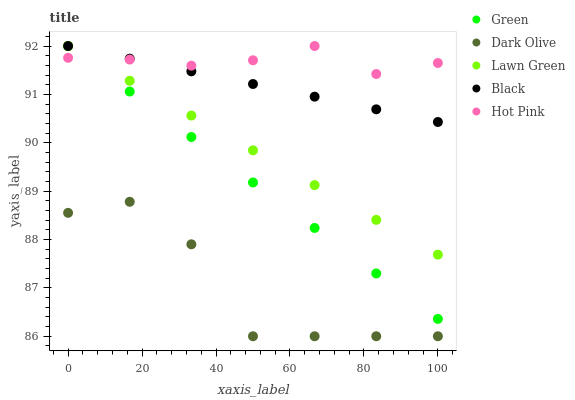Does Dark Olive have the minimum area under the curve?
Answer yes or no. Yes. Does Hot Pink have the maximum area under the curve?
Answer yes or no. Yes. Does Green have the minimum area under the curve?
Answer yes or no. No. Does Green have the maximum area under the curve?
Answer yes or no. No. Is Black the smoothest?
Answer yes or no. Yes. Is Dark Olive the roughest?
Answer yes or no. Yes. Is Green the smoothest?
Answer yes or no. No. Is Green the roughest?
Answer yes or no. No. Does Dark Olive have the lowest value?
Answer yes or no. Yes. Does Green have the lowest value?
Answer yes or no. No. Does Hot Pink have the highest value?
Answer yes or no. Yes. Does Dark Olive have the highest value?
Answer yes or no. No. Is Dark Olive less than Green?
Answer yes or no. Yes. Is Hot Pink greater than Dark Olive?
Answer yes or no. Yes. Does Black intersect Hot Pink?
Answer yes or no. Yes. Is Black less than Hot Pink?
Answer yes or no. No. Is Black greater than Hot Pink?
Answer yes or no. No. Does Dark Olive intersect Green?
Answer yes or no. No. 